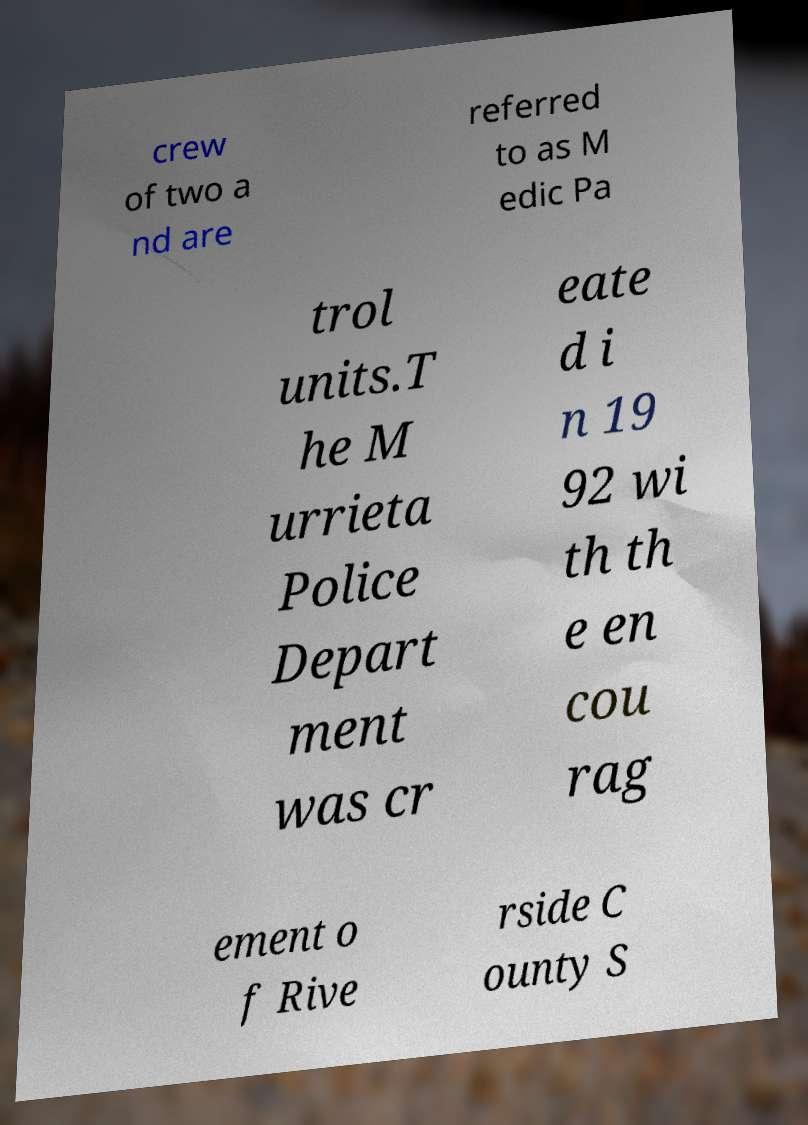Please read and relay the text visible in this image. What does it say? crew of two a nd are referred to as M edic Pa trol units.T he M urrieta Police Depart ment was cr eate d i n 19 92 wi th th e en cou rag ement o f Rive rside C ounty S 